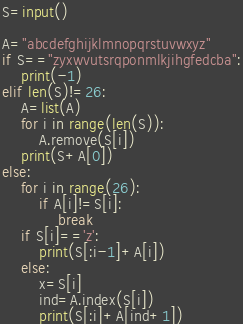<code> <loc_0><loc_0><loc_500><loc_500><_Python_>S=input()

A="abcdefghijklmnopqrstuvwxyz"
if S=="zyxwvutsrqponmlkjihgfedcba":
    print(-1)
elif len(S)!=26:
    A=list(A)
    for i in range(len(S)):
        A.remove(S[i])
    print(S+A[0])
else:
    for i in range(26):
        if A[i]!=S[i]:
            break
    if S[i]=='z':
        print(S[:i-1]+A[i])
    else:
        x=S[i]
        ind=A.index(S[i])
        print(S[:i]+A[ind+1])
</code> 